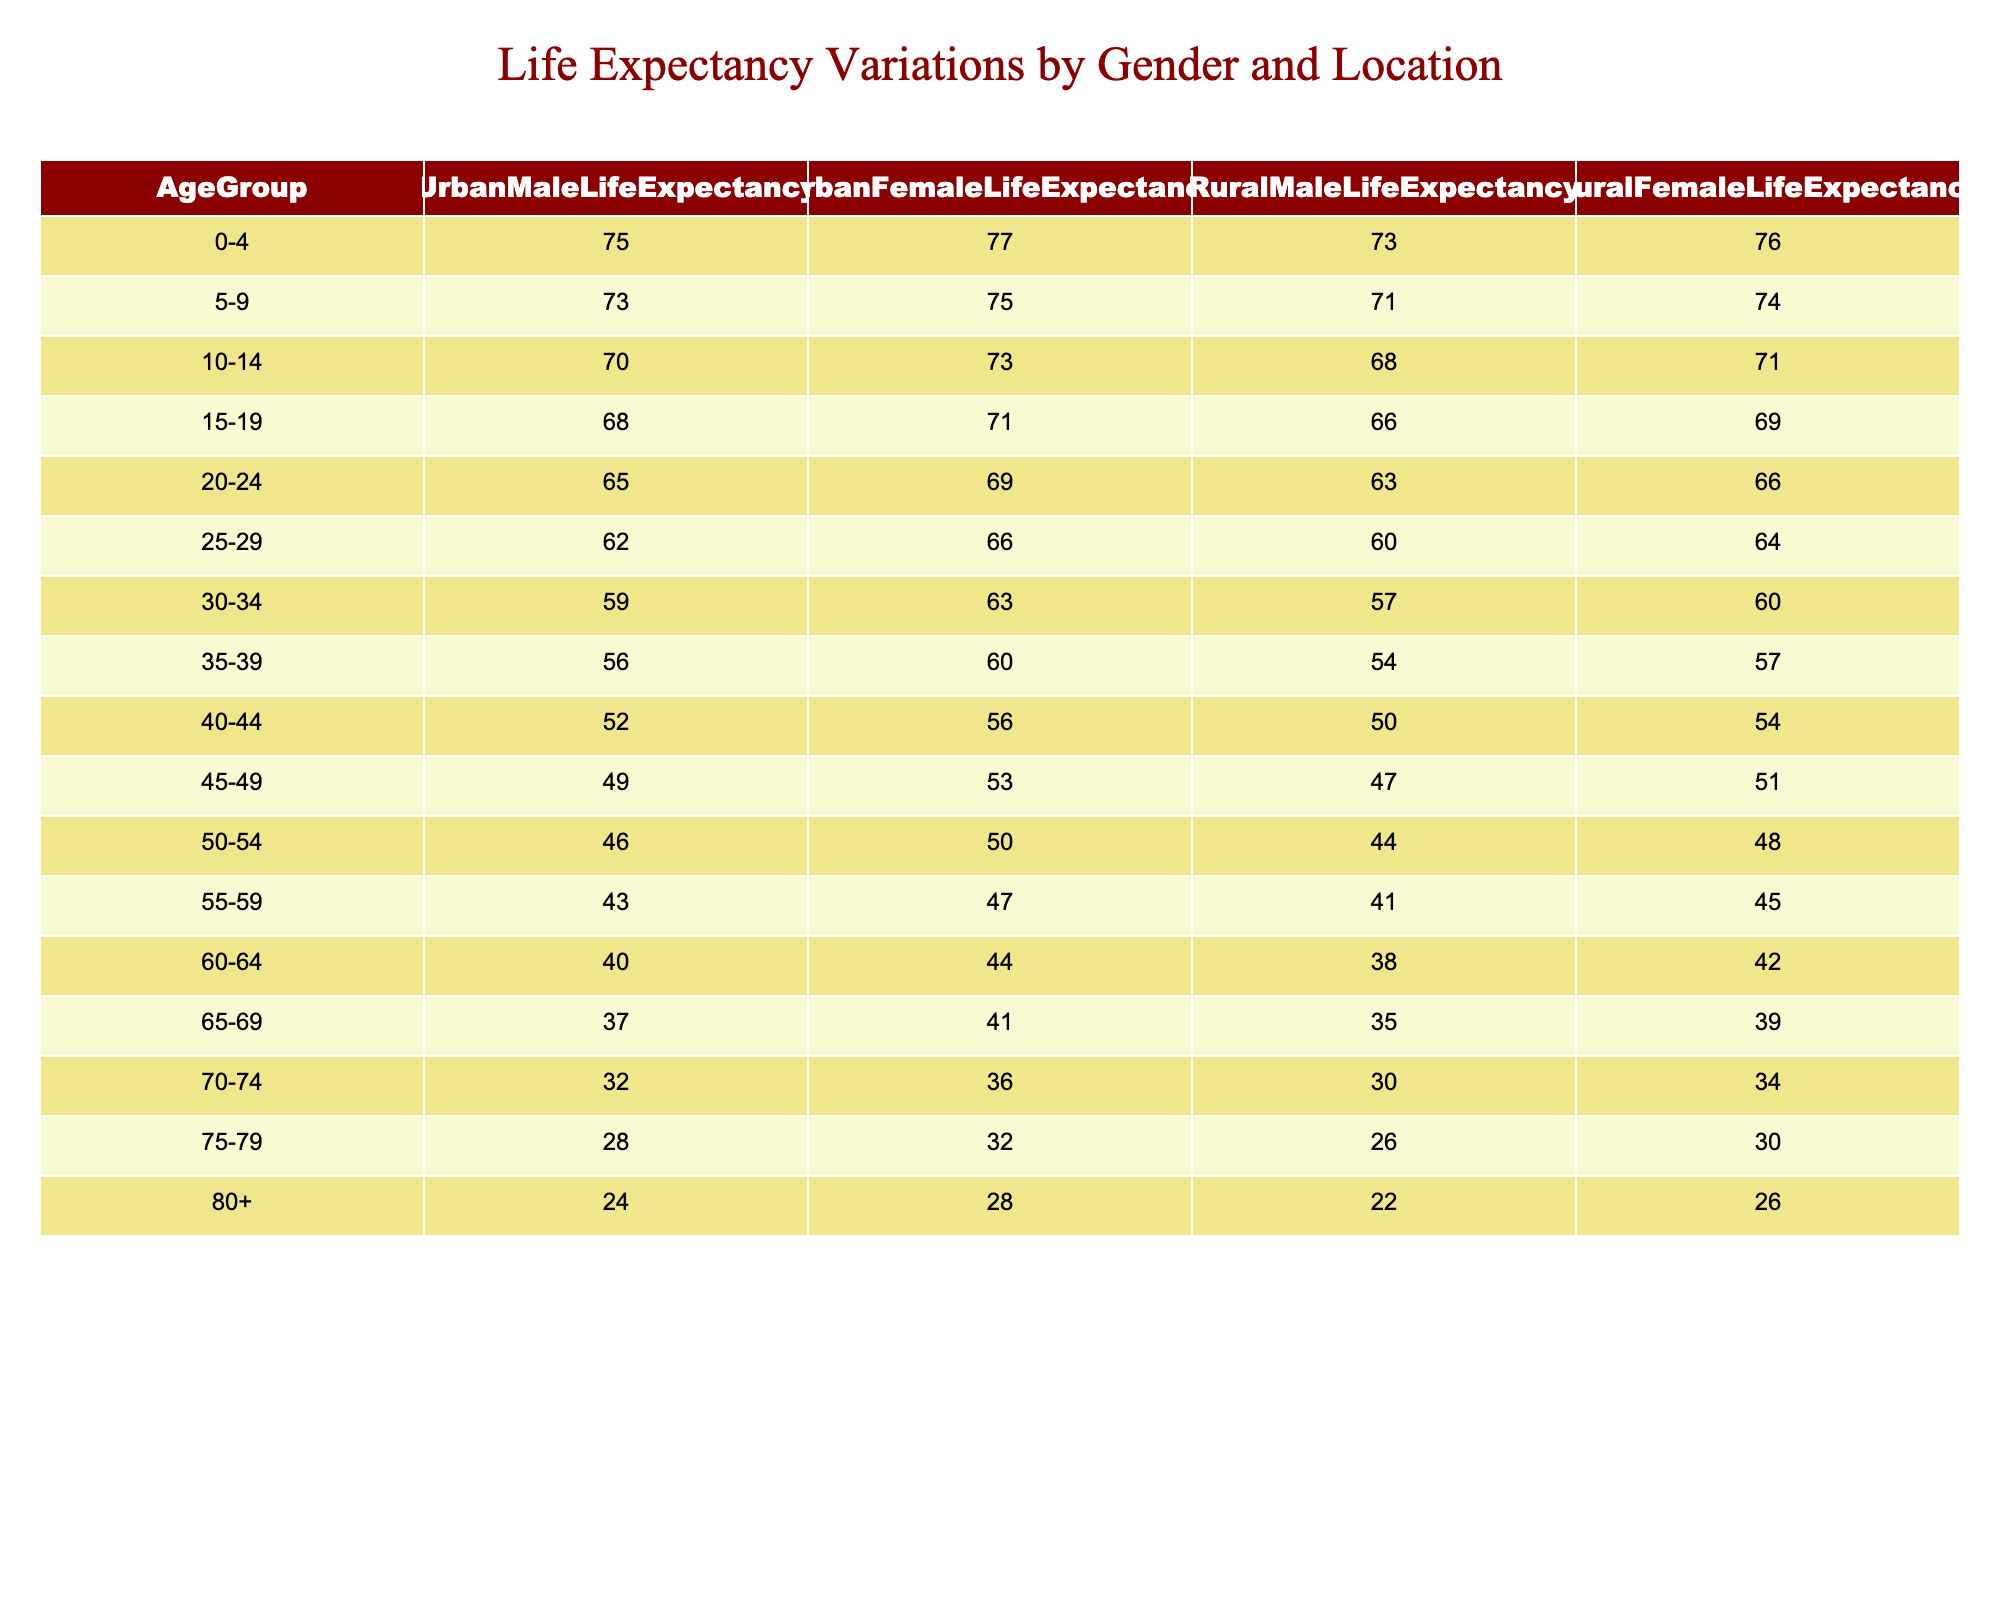What is the life expectancy for urban males aged 60-64? From the table, under the column for Urban Male Life Expectancy and the row for the age group 60-64, the value is 40.
Answer: 40 What is the difference in life expectancy between urban and rural females for the age group 50-54? For urban females aged 50-54, the life expectancy is 50, and for rural females, it is 48. The difference is calculated as 50 - 48 = 2.
Answer: 2 Do rural males live longer than urban males in the 25-29 age group? In the 25-29 age group, urban males have a life expectancy of 62, while rural males have a life expectancy of 60. Since 62 is greater than 60, the statement is false.
Answer: No What is the average life expectancy for urban females across all age groups? To find the average for urban females, sum the life expectancies: 77 + 75 + 73 + 71 + 69 + 66 + 63 + 60 + 56 + 53 + 50 + 47 + 44 + 41 + 36 + 32 + 28 = 1019. There are 17 age groups, so the average is 1019/17 = approximately 59.94.
Answer: 59.94 Which age group has the highest life expectancy for rural males? Looking at the table, the highest life expectancy for rural males is found in the age group 0-4, where it is 73.
Answer: 73 What are the life expectancies for urban and rural females aged 70-74? In the age group 70-74, urban females have a life expectancy of 36 and rural females have a life expectancy of 34.
Answer: Urban: 36, Rural: 34 Are urban males in the age group 45-49 expected to live longer than rural females in the same age group? Urban males in the 45-49 age group have a life expectancy of 49, while rural females have a life expectancy of 51. Since 49 is less than 51, the statement is false.
Answer: No Calculate the total life expectancy for both urban and rural males combined in the 65-69 age group. For urban males, the life expectancy is 37, and for rural males, it is 35. Adding these together gives 37 + 35 = 72.
Answer: 72 Which gender has a higher life expectancy at older ages, 75-79 for urban populations? In the 75-79 age group for urban populations, the life expectancy for females is 32, while for males, it is 28. Therefore, females have a higher life expectancy.
Answer: Females 